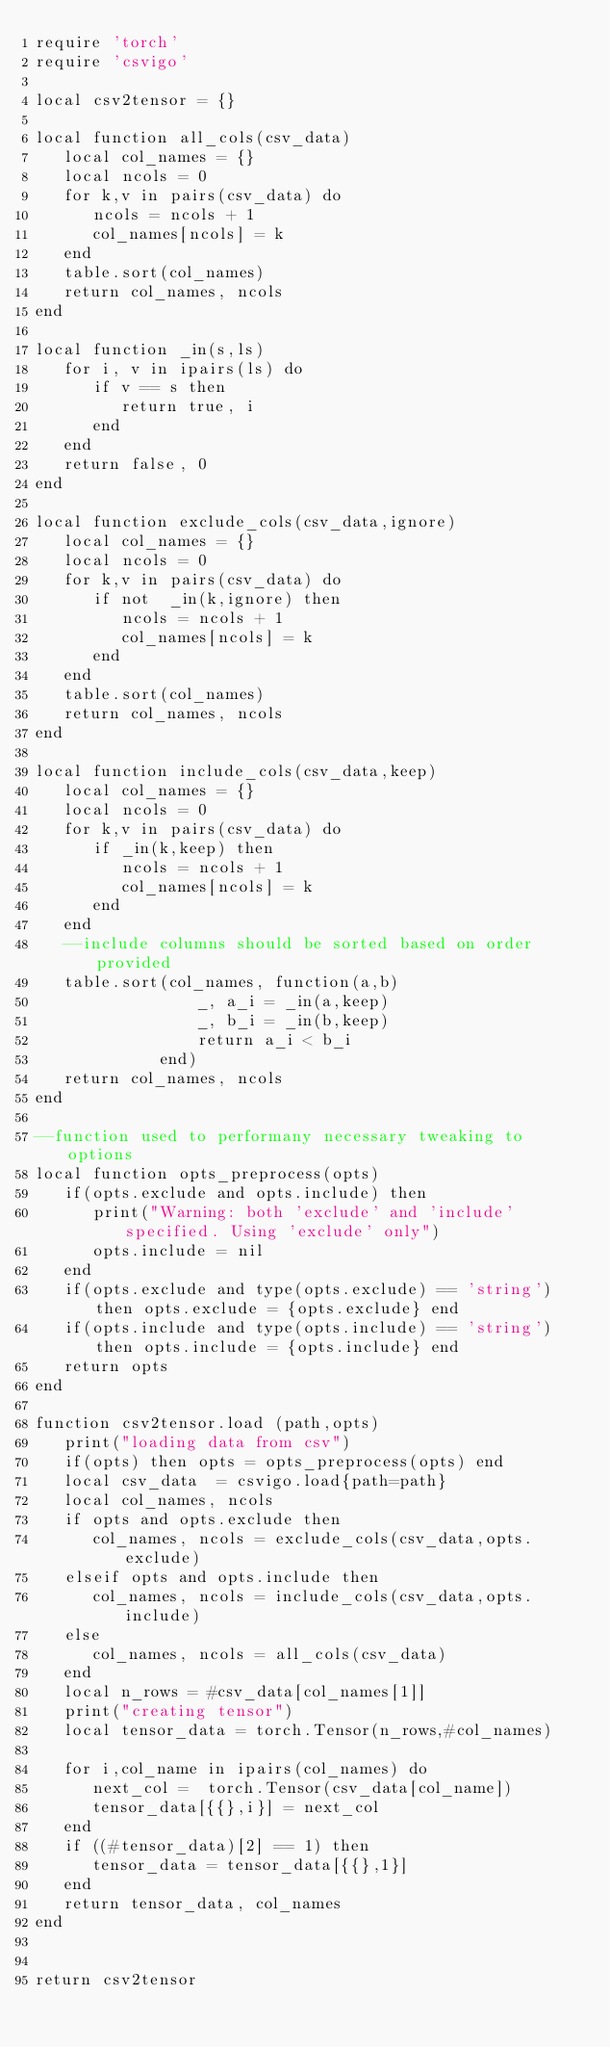Convert code to text. <code><loc_0><loc_0><loc_500><loc_500><_Lua_>require 'torch'
require 'csvigo'

local csv2tensor = {}

local function all_cols(csv_data)
   local col_names = {}
   local ncols = 0
   for k,v in pairs(csv_data) do
      ncols = ncols + 1
      col_names[ncols] = k
   end
   table.sort(col_names)
   return col_names, ncols
end

local function _in(s,ls)
   for i, v in ipairs(ls) do
      if v == s then
         return true, i
      end
   end
   return false, 0
end

local function exclude_cols(csv_data,ignore)
   local col_names = {}
   local ncols = 0
   for k,v in pairs(csv_data) do
      if not  _in(k,ignore) then
         ncols = ncols + 1
         col_names[ncols] = k
      end
   end
   table.sort(col_names)
   return col_names, ncols
end

local function include_cols(csv_data,keep)
   local col_names = {}
   local ncols = 0
   for k,v in pairs(csv_data) do
      if _in(k,keep) then
         ncols = ncols + 1
         col_names[ncols] = k
      end
   end
   --include columns should be sorted based on order provided
   table.sort(col_names, function(a,b) 
                 _, a_i = _in(a,keep)
                 _, b_i = _in(b,keep)
                 return a_i < b_i
             end)
   return col_names, ncols
end

--function used to performany necessary tweaking to options
local function opts_preprocess(opts)
   if(opts.exclude and opts.include) then
      print("Warning: both 'exclude' and 'include' specified. Using 'exclude' only")
      opts.include = nil
   end
   if(opts.exclude and type(opts.exclude) == 'string') then opts.exclude = {opts.exclude} end
   if(opts.include and type(opts.include) == 'string') then opts.include = {opts.include} end
   return opts
end

function csv2tensor.load (path,opts)
   print("loading data from csv")
   if(opts) then opts = opts_preprocess(opts) end
   local csv_data  = csvigo.load{path=path}
   local col_names, ncols
   if opts and opts.exclude then
      col_names, ncols = exclude_cols(csv_data,opts.exclude)
   elseif opts and opts.include then
      col_names, ncols = include_cols(csv_data,opts.include)
   else
      col_names, ncols = all_cols(csv_data)
   end
   local n_rows = #csv_data[col_names[1]]
   print("creating tensor")
   local tensor_data = torch.Tensor(n_rows,#col_names)
   
   for i,col_name in ipairs(col_names) do
      next_col =  torch.Tensor(csv_data[col_name])
      tensor_data[{{},i}] = next_col
   end
   if ((#tensor_data)[2] == 1) then 
      tensor_data = tensor_data[{{},1}]
   end
   return tensor_data, col_names
end


return csv2tensor
</code> 